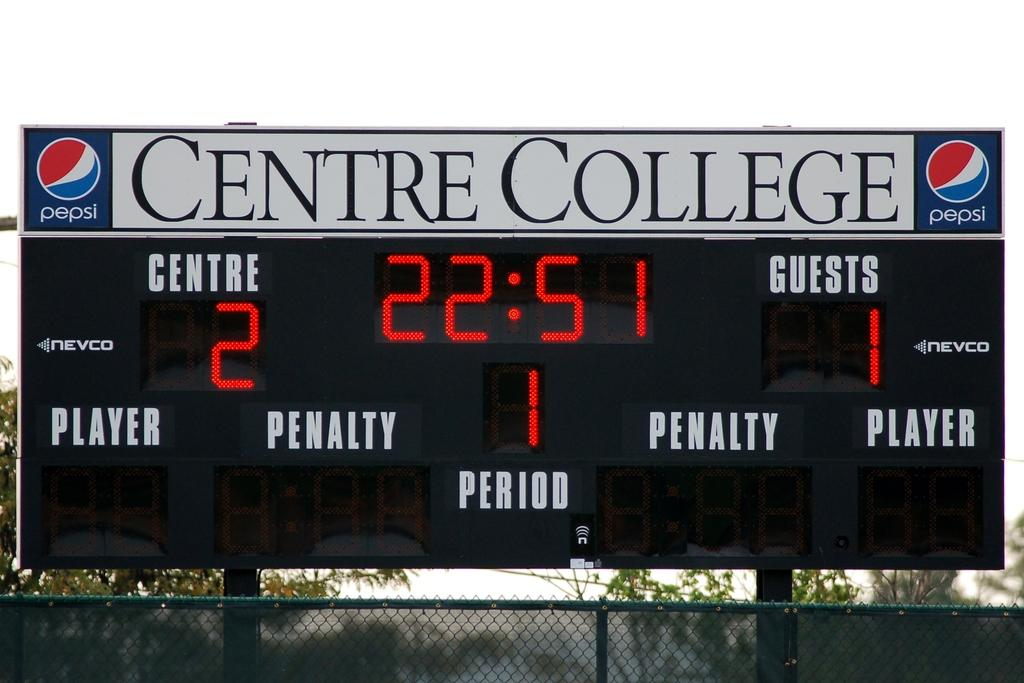<image>
Share a concise interpretation of the image provided. A Centre College sports scoreboard showing that Centre is leading the guest team 2 to 1 in the 1st period. 